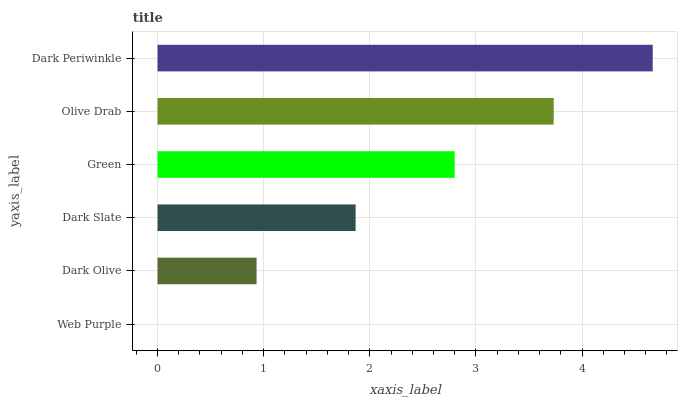Is Web Purple the minimum?
Answer yes or no. Yes. Is Dark Periwinkle the maximum?
Answer yes or no. Yes. Is Dark Olive the minimum?
Answer yes or no. No. Is Dark Olive the maximum?
Answer yes or no. No. Is Dark Olive greater than Web Purple?
Answer yes or no. Yes. Is Web Purple less than Dark Olive?
Answer yes or no. Yes. Is Web Purple greater than Dark Olive?
Answer yes or no. No. Is Dark Olive less than Web Purple?
Answer yes or no. No. Is Green the high median?
Answer yes or no. Yes. Is Dark Slate the low median?
Answer yes or no. Yes. Is Dark Slate the high median?
Answer yes or no. No. Is Web Purple the low median?
Answer yes or no. No. 